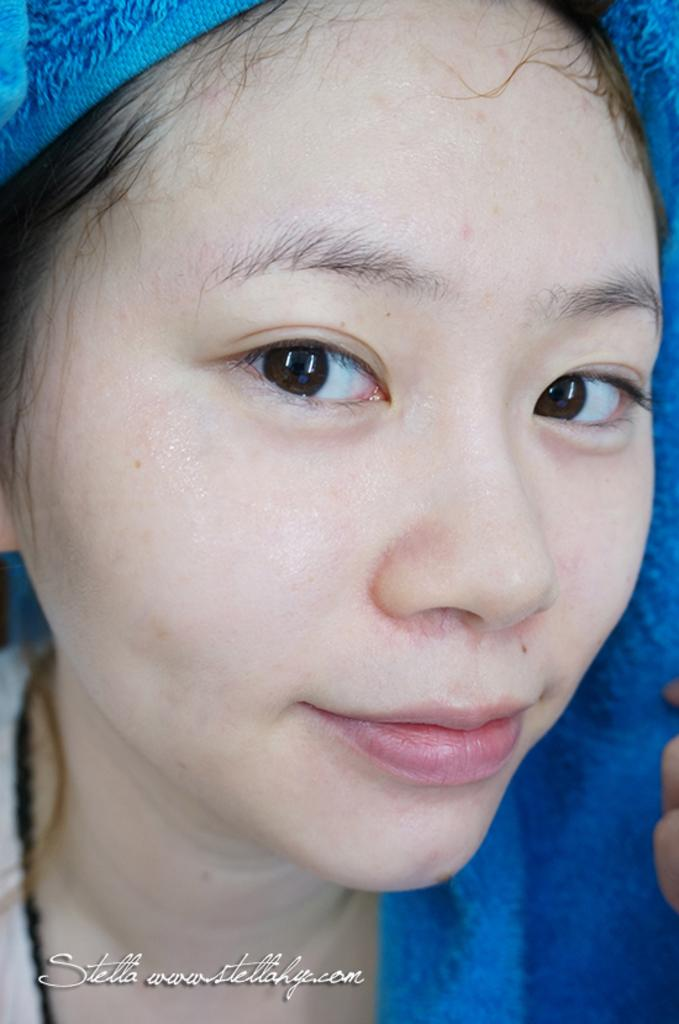Who is present in the image? There is a woman in the image. What can be found at the bottom of the image? There is text at the bottom of the image. How many friends can be seen with the woman in the image? There is no mention of friends in the image, as it only features a woman. Is there a snake visible in the image? There is no snake present in the image. 